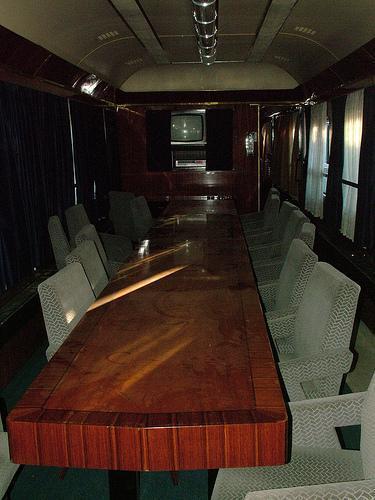How many televisions are there?
Give a very brief answer. 1. 